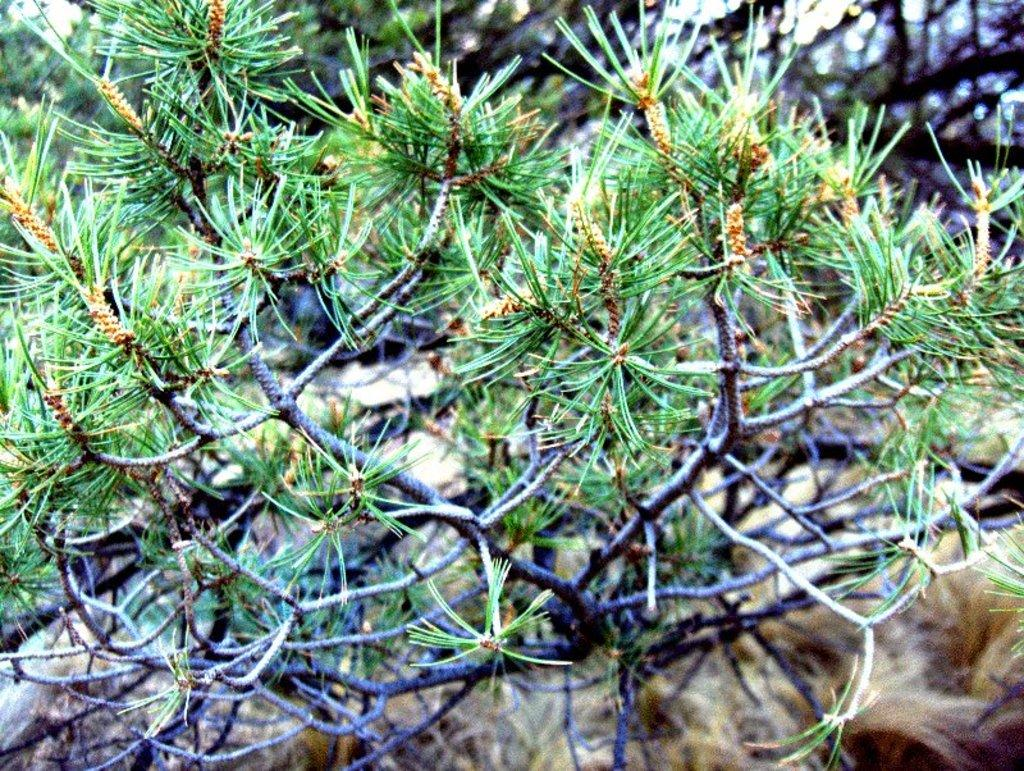What is located in the front of the image? There are plants in the front of the image. Can you describe the background of the image? The background of the image is blurry. What nation is represented by the plants in the image? The image does not represent any specific nation, as it only features plants. What time of day is it during the recess in the image? There is no indication of a recess or time of day in the image, as it only features plants and a blurry background. 